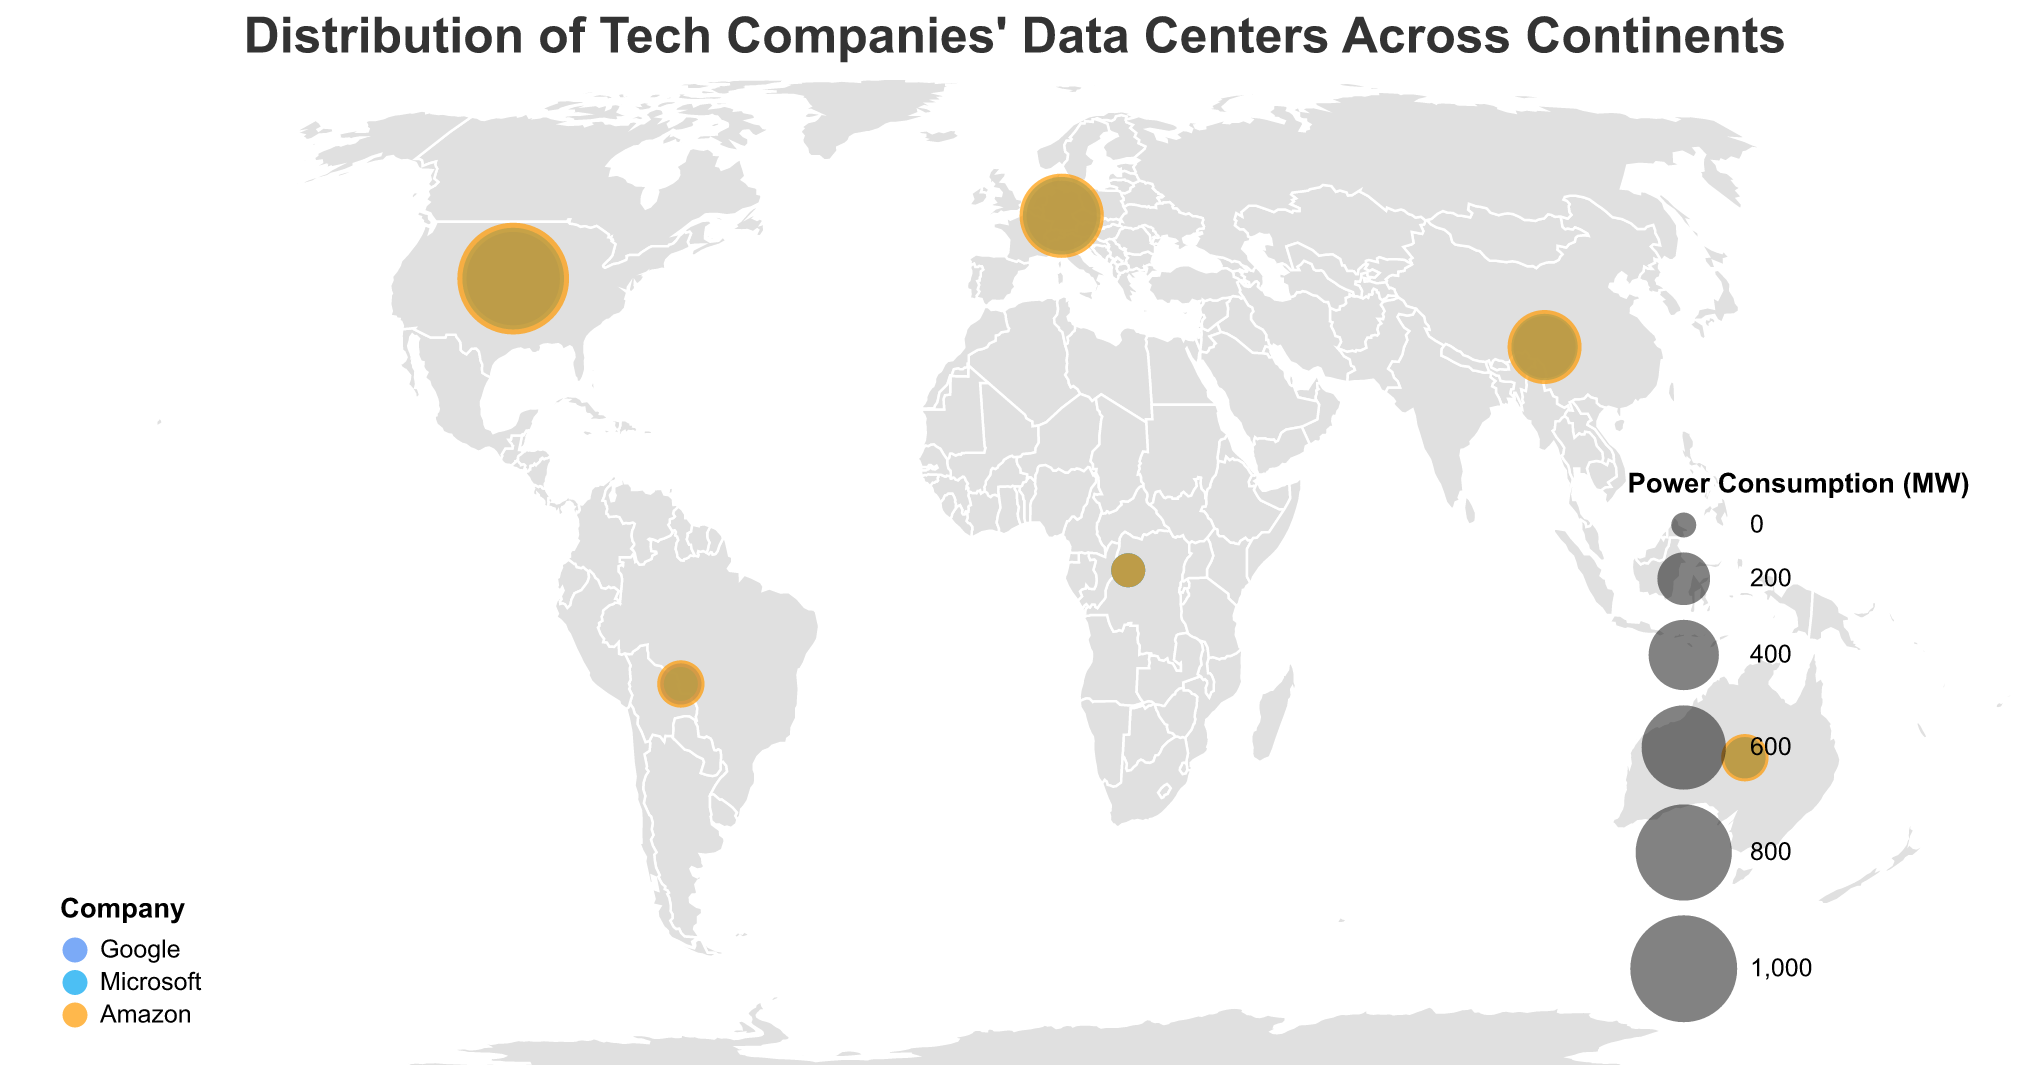What's the title of the figure? The title is generally placed at the top of the figure. Here, it's clearly mentioned as "Distribution of Tech Companies' Data Centers Across Continents" at the top.
Answer: Distribution of Tech Companies' Data Centers Across Continents What does the size of the circles represent? Based on the legend provided in the figure, the size of the circles represents the "Power Consumption (MW)" of the data centers. Larger circles correspond to higher power consumption.
Answer: Power Consumption (MW) Which company has the most data centers in North America? By looking at the data points in North America and referring to the 'Data Centers' field in the tooltips, Amazon has 22 data centers in North America which is the highest among the companies.
Answer: Amazon What is the total number of data centers in Europe for all companies combined? Sum the number of data centers for Google, Microsoft, and Amazon in Europe. Google: 8, Microsoft: 10, Amazon: 12. Total = 8 + 10 + 12 = 30.
Answer: 30 Which continent has the least power consumption for Google data centers? Refer to the 'Power Consumption (MW)' field for Google in each continent. Africa and South America have the lowest, with 50 MW each.
Answer: Africa and South America How does the power consumption in Europe compare between Google and Microsoft? Look at the power consumption for the companies in Europe. Google: 400 MW, Microsoft: 500 MW. Microsoft consumes more power.
Answer: Microsoft consumes more power On which continent does Amazon have the highest number of data centers? Check Amazon's data centers count across all continents. North America has the highest at 22 data centers.
Answer: North America What's the combined power consumption of data centers for Microsoft in Asia and South America? Microsoft's power consumption in Asia: 350 MW, South America: 50 MW. Combined = 350 + 50 = 400 MW.
Answer: 400 MW Which continent has the highest total power consumption for all companies combined? Compute the total power consumption per continent from the provided data. North America has the highest. Google: 750 MW, Microsoft: 900 MW, Amazon: 1100 MW. Total = 750 + 900 + 1100 = 2750 MW.
Answer: North America If a new data center is added in Europe for Amazon, increasing their total power consumption by 100 MW, what will be Amazon's new power consumption in Europe? Current power consumption for Amazon in Europe is 600 MW. With the new data center, it will be 600 + 100 = 700 MW.
Answer: 700 MW 